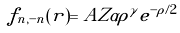<formula> <loc_0><loc_0><loc_500><loc_500>f _ { n , - n } ( r ) = A Z \alpha \rho ^ { \gamma } e ^ { - \rho / 2 }</formula> 